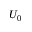<formula> <loc_0><loc_0><loc_500><loc_500>U _ { 0 }</formula> 